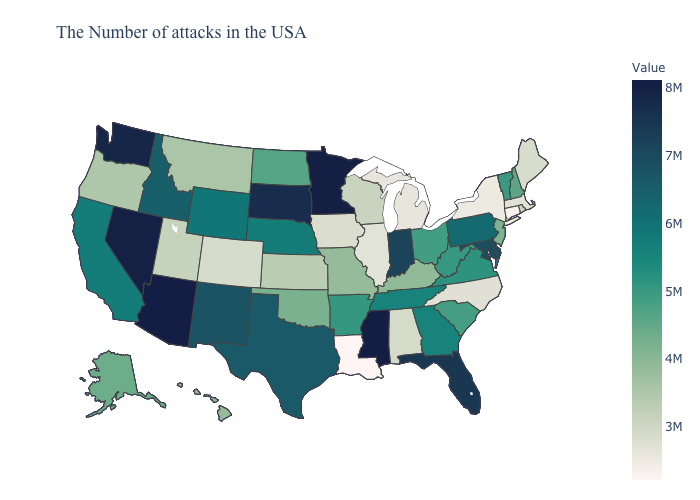Does Louisiana have the lowest value in the USA?
Write a very short answer. Yes. Does Colorado have the lowest value in the West?
Quick response, please. Yes. Does Arizona have the highest value in the USA?
Give a very brief answer. Yes. Is the legend a continuous bar?
Write a very short answer. Yes. Which states have the lowest value in the South?
Keep it brief. Louisiana. Does Oregon have the highest value in the West?
Quick response, please. No. Is the legend a continuous bar?
Quick response, please. Yes. 